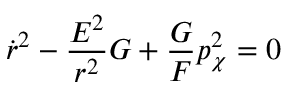<formula> <loc_0><loc_0><loc_500><loc_500>\dot { r } ^ { 2 } - \frac { E ^ { 2 } } { r ^ { 2 } } G + \frac { G } { F } p _ { \chi } ^ { 2 } = 0</formula> 